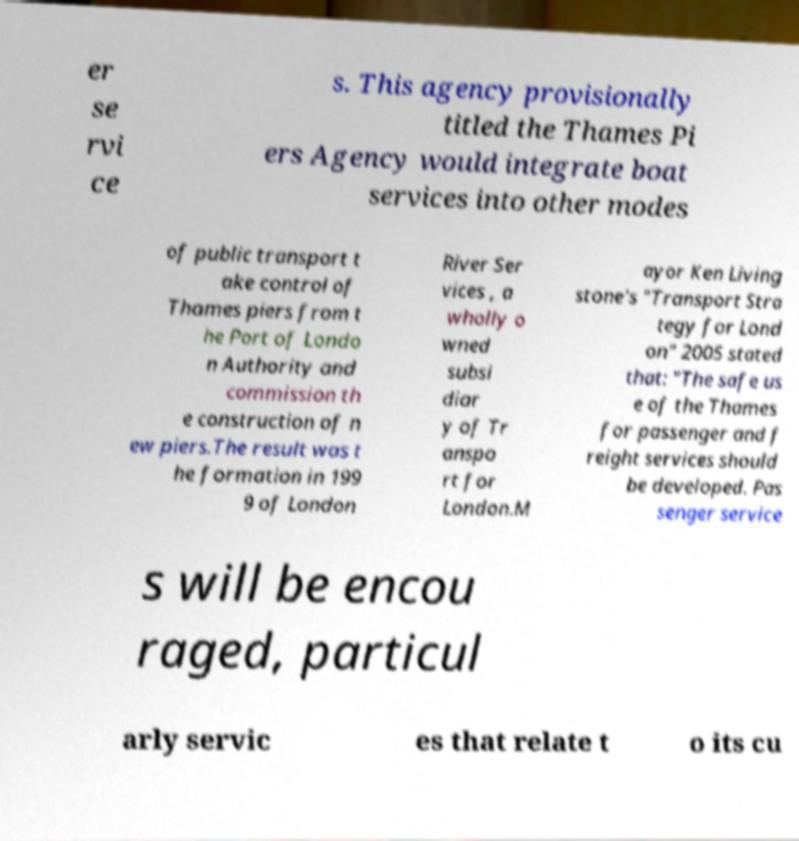Could you assist in decoding the text presented in this image and type it out clearly? er se rvi ce s. This agency provisionally titled the Thames Pi ers Agency would integrate boat services into other modes of public transport t ake control of Thames piers from t he Port of Londo n Authority and commission th e construction of n ew piers.The result was t he formation in 199 9 of London River Ser vices , a wholly o wned subsi diar y of Tr anspo rt for London.M ayor Ken Living stone's "Transport Stra tegy for Lond on" 2005 stated that: "The safe us e of the Thames for passenger and f reight services should be developed. Pas senger service s will be encou raged, particul arly servic es that relate t o its cu 